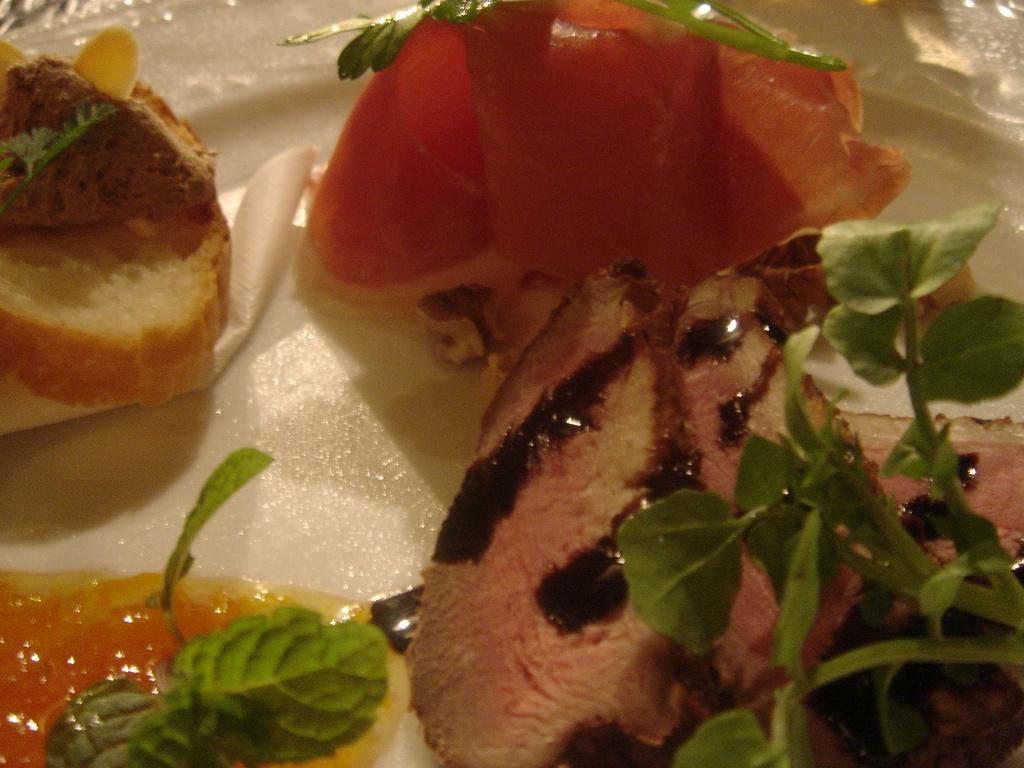Please provide a concise description of this image. In this image we can see some food items and leaves on the plate. 